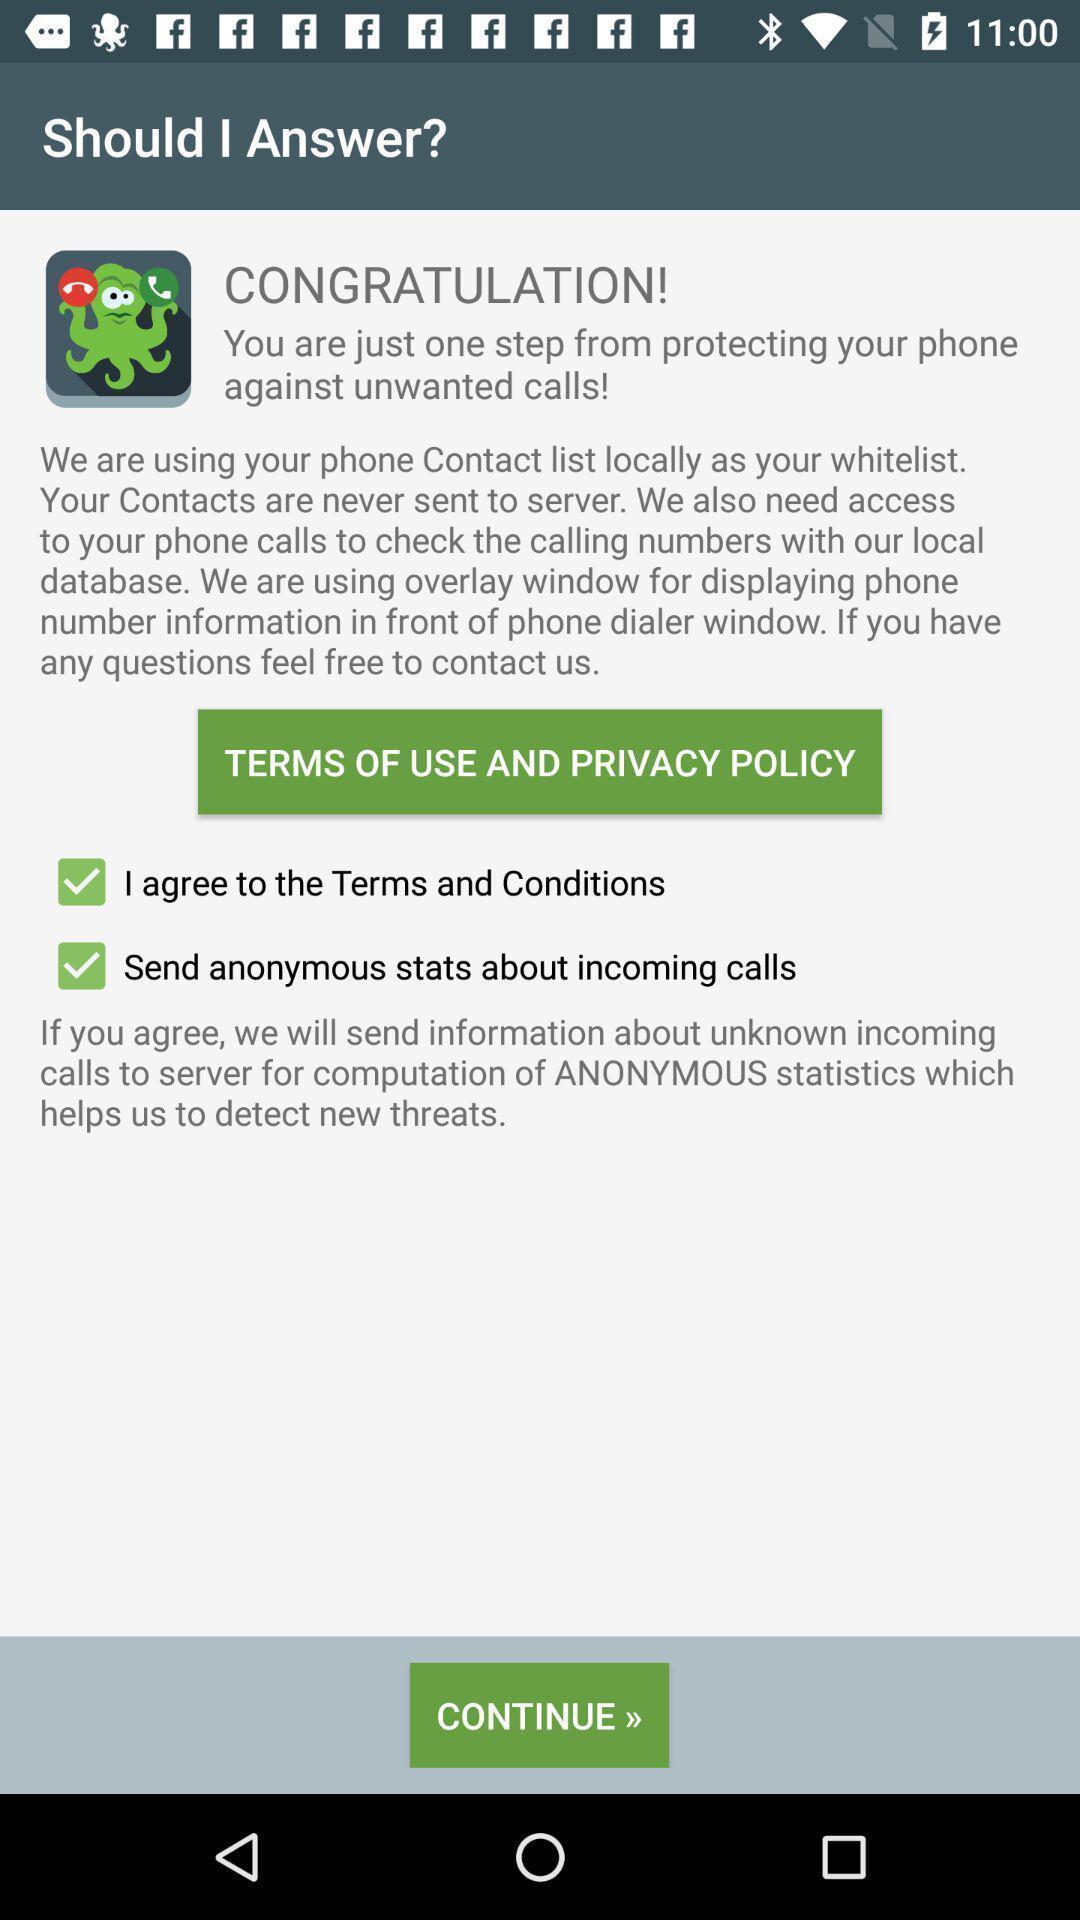Give me a summary of this screen capture. Terms and privacy policy of the app. 